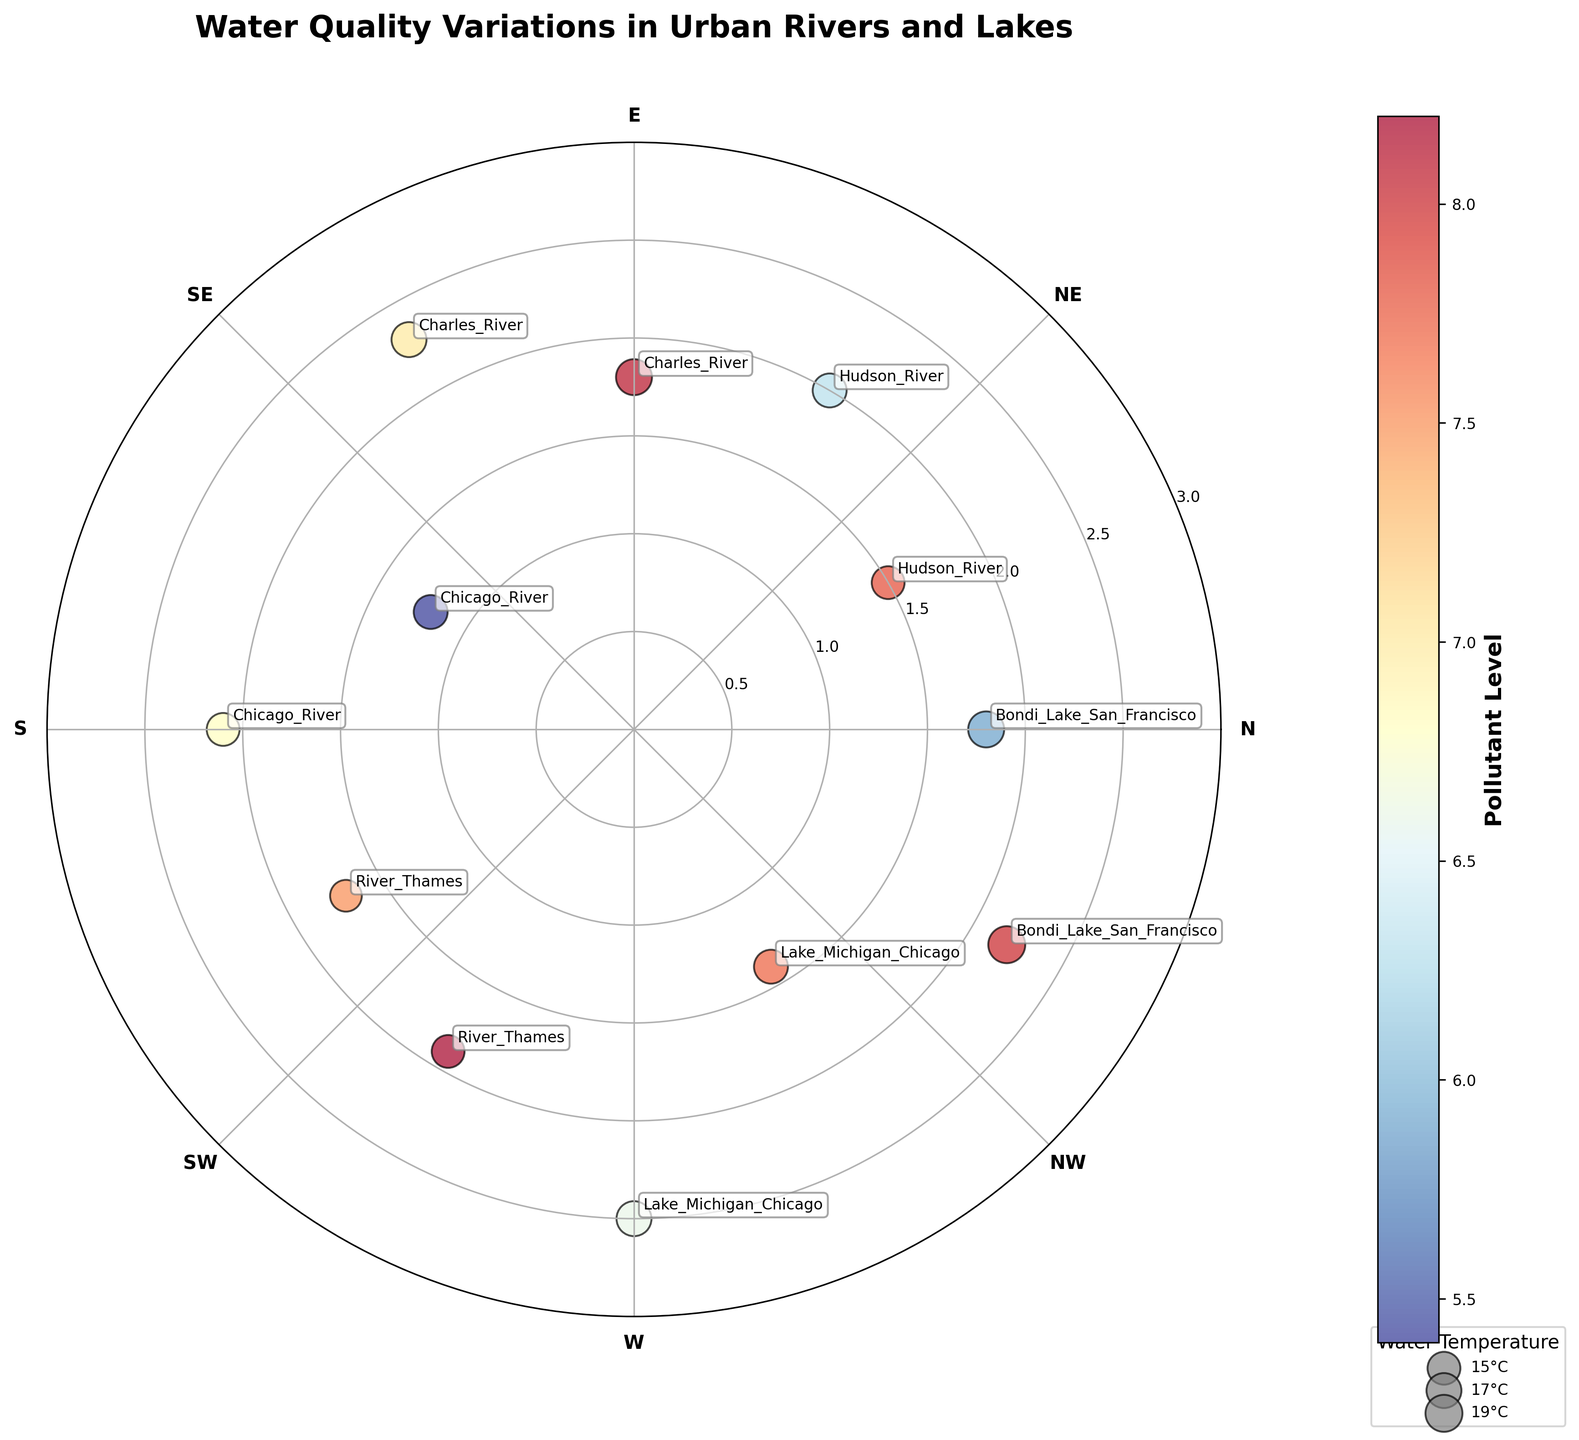What is the title of the plot? The title is prominently displayed at the top of the figure. It reads "Water Quality Variations in Urban Rivers and Lakes".
Answer: Water Quality Variations in Urban Rivers and Lakes Which river has the highest Pollutant Level? By examining the color scale and the color of points, the point corresponding to the Hudson River at 30 degrees has the highest intensity which is indicated by the color bar.
Answer: Hudson River What are the y-axis (radial axis) limits? The y-axis (or radial axis) is visibly labeled as ranging from 0 to 3.0, with ticks at every 0.5 intervals.
Answer: 0 to 3 Which data point has the highest water temperature? The size of the points indicates the water temperature. The largest point corresponds to Bondi Lake in San Francisco at 330 degrees.
Answer: Bondi Lake San Francisco at 330 degrees What is the water temperature of the River Thames data point at 210 degrees? Looking at the size of the points and the legend mappings, the River Thames at 210 degrees is smaller in size compared to the largest point, indicating a water temperature around 14-15°C.
Answer: 14°C to 15°C Compare the Pollutant Levels of the Charles River at 90 degrees and 120 degrees. Which is higher? By checking the color of the points and referencing the color bar, the pollutant level at 120 degrees (7.0) is less intense compared to 90 degrees (8.1).
Answer: 90 degrees Which river has better water clarity, the Hudson or the Charles River? By checking the provided distances of Hudson River points (1.5 and 2.0) and Charles River points (1.8 and 2.3), and taking the distance inversely proportional to water clarity (closer is less clear), the Charles River has farther points implying it has better water clarity.
Answer: Charles River Are the data points for Chicago River on the same radial distance? If not, which one's farther? By comparing the distances, the Chicago River points at 150 degrees and 180 degrees have different distances (1.2 and 2.1). The point at 180 degrees (2.1) is farther.
Answer: No, 180 degrees is farther What is the average pollutant level in Bondi Lake, San Francisco? Bondi Lake points are at 330 and 360 degrees with pollutant levels 8.0 and 5.9. Average is calculated as (8.0 + 5.9) / 2 = 6.95.
Answer: 6.95 